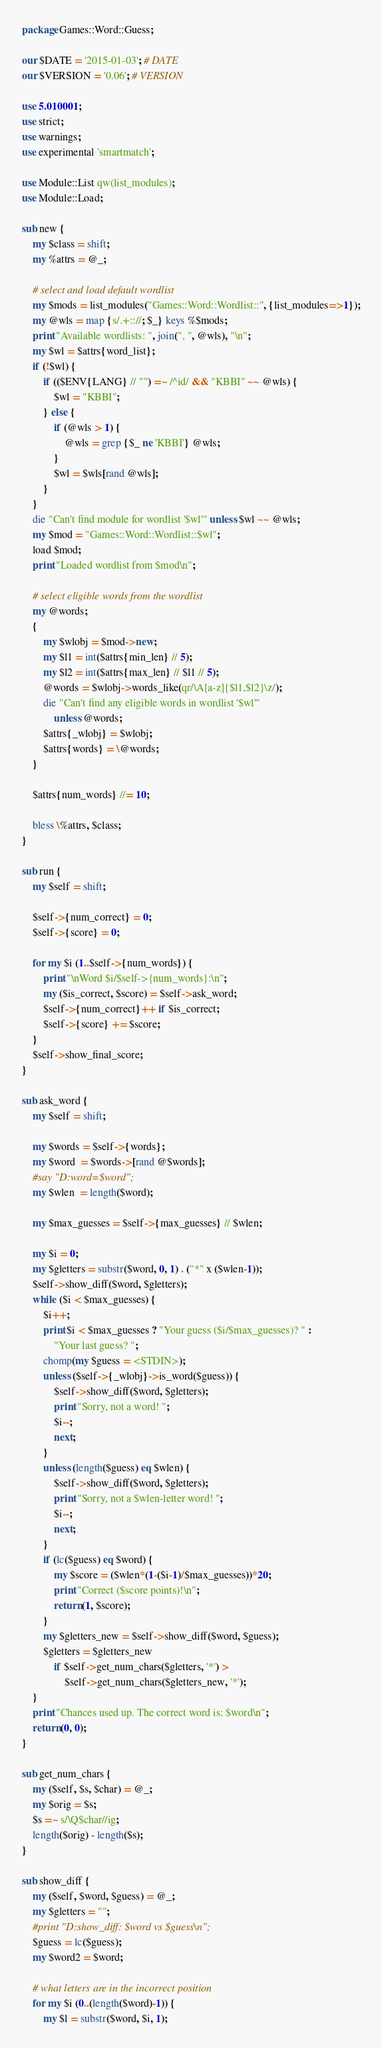Convert code to text. <code><loc_0><loc_0><loc_500><loc_500><_Perl_>package Games::Word::Guess;

our $DATE = '2015-01-03'; # DATE
our $VERSION = '0.06'; # VERSION

use 5.010001;
use strict;
use warnings;
use experimental 'smartmatch';

use Module::List qw(list_modules);
use Module::Load;

sub new {
    my $class = shift;
    my %attrs = @_;

    # select and load default wordlist
    my $mods = list_modules("Games::Word::Wordlist::", {list_modules=>1});
    my @wls = map {s/.+:://; $_} keys %$mods;
    print "Available wordlists: ", join(", ", @wls), "\n";
    my $wl = $attrs{word_list};
    if (!$wl) {
        if (($ENV{LANG} // "") =~ /^id/ && "KBBI" ~~ @wls) {
            $wl = "KBBI";
        } else {
            if (@wls > 1) {
                @wls = grep {$_ ne 'KBBI'} @wls;
            }
            $wl = $wls[rand @wls];
        }
    }
    die "Can't find module for wordlist '$wl'" unless $wl ~~ @wls;
    my $mod = "Games::Word::Wordlist::$wl";
    load $mod;
    print "Loaded wordlist from $mod\n";

    # select eligible words from the wordlist
    my @words;
    {
        my $wlobj = $mod->new;
        my $l1 = int($attrs{min_len} // 5);
        my $l2 = int($attrs{max_len} // $l1 // 5);
        @words = $wlobj->words_like(qr/\A[a-z]{$l1,$l2}\z/);
        die "Can't find any eligible words in wordlist '$wl'"
            unless @words;
        $attrs{_wlobj} = $wlobj;
        $attrs{words} = \@words;
    }

    $attrs{num_words} //= 10;

    bless \%attrs, $class;
}

sub run {
    my $self = shift;

    $self->{num_correct} = 0;
    $self->{score} = 0;

    for my $i (1..$self->{num_words}) {
        print "\nWord $i/$self->{num_words}:\n";
        my ($is_correct, $score) = $self->ask_word;
        $self->{num_correct}++ if $is_correct;
        $self->{score} += $score;
    }
    $self->show_final_score;
}

sub ask_word {
    my $self = shift;

    my $words = $self->{words};
    my $word  = $words->[rand @$words];
    #say "D:word=$word";
    my $wlen  = length($word);

    my $max_guesses = $self->{max_guesses} // $wlen;

    my $i = 0;
    my $gletters = substr($word, 0, 1) . ("*" x ($wlen-1));
    $self->show_diff($word, $gletters);
    while ($i < $max_guesses) {
        $i++;
        print $i < $max_guesses ? "Your guess ($i/$max_guesses)? " :
            "Your last guess? ";
        chomp(my $guess = <STDIN>);
        unless ($self->{_wlobj}->is_word($guess)) {
            $self->show_diff($word, $gletters);
            print "Sorry, not a word! ";
            $i--;
            next;
        }
        unless (length($guess) eq $wlen) {
            $self->show_diff($word, $gletters);
            print "Sorry, not a $wlen-letter word! ";
            $i--;
            next;
        }
        if (lc($guess) eq $word) {
            my $score = ($wlen*(1-($i-1)/$max_guesses))*20;
            print "Correct ($score points)!\n";
            return (1, $score);
        }
        my $gletters_new = $self->show_diff($word, $guess);
        $gletters = $gletters_new
            if $self->get_num_chars($gletters, '*') >
                $self->get_num_chars($gletters_new, '*');
    }
    print "Chances used up. The correct word is: $word\n";
    return (0, 0);
}

sub get_num_chars {
    my ($self, $s, $char) = @_;
    my $orig = $s;
    $s =~ s/\Q$char//ig;
    length($orig) - length($s);
}

sub show_diff {
    my ($self, $word, $guess) = @_;
    my $gletters = "";
    #print "D:show_diff: $word vs $guess\n";
    $guess = lc($guess);
    my $word2 = $word;

    # what letters are in the incorrect position
    for my $i (0..(length($word)-1)) {
        my $l = substr($word, $i, 1);</code> 